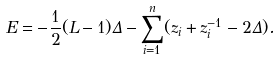Convert formula to latex. <formula><loc_0><loc_0><loc_500><loc_500>E = - \frac { 1 } { 2 } ( L - 1 ) \Delta - \sum _ { i = 1 } ^ { n } ( z _ { i } + z _ { i } ^ { - 1 } - 2 \Delta ) .</formula> 